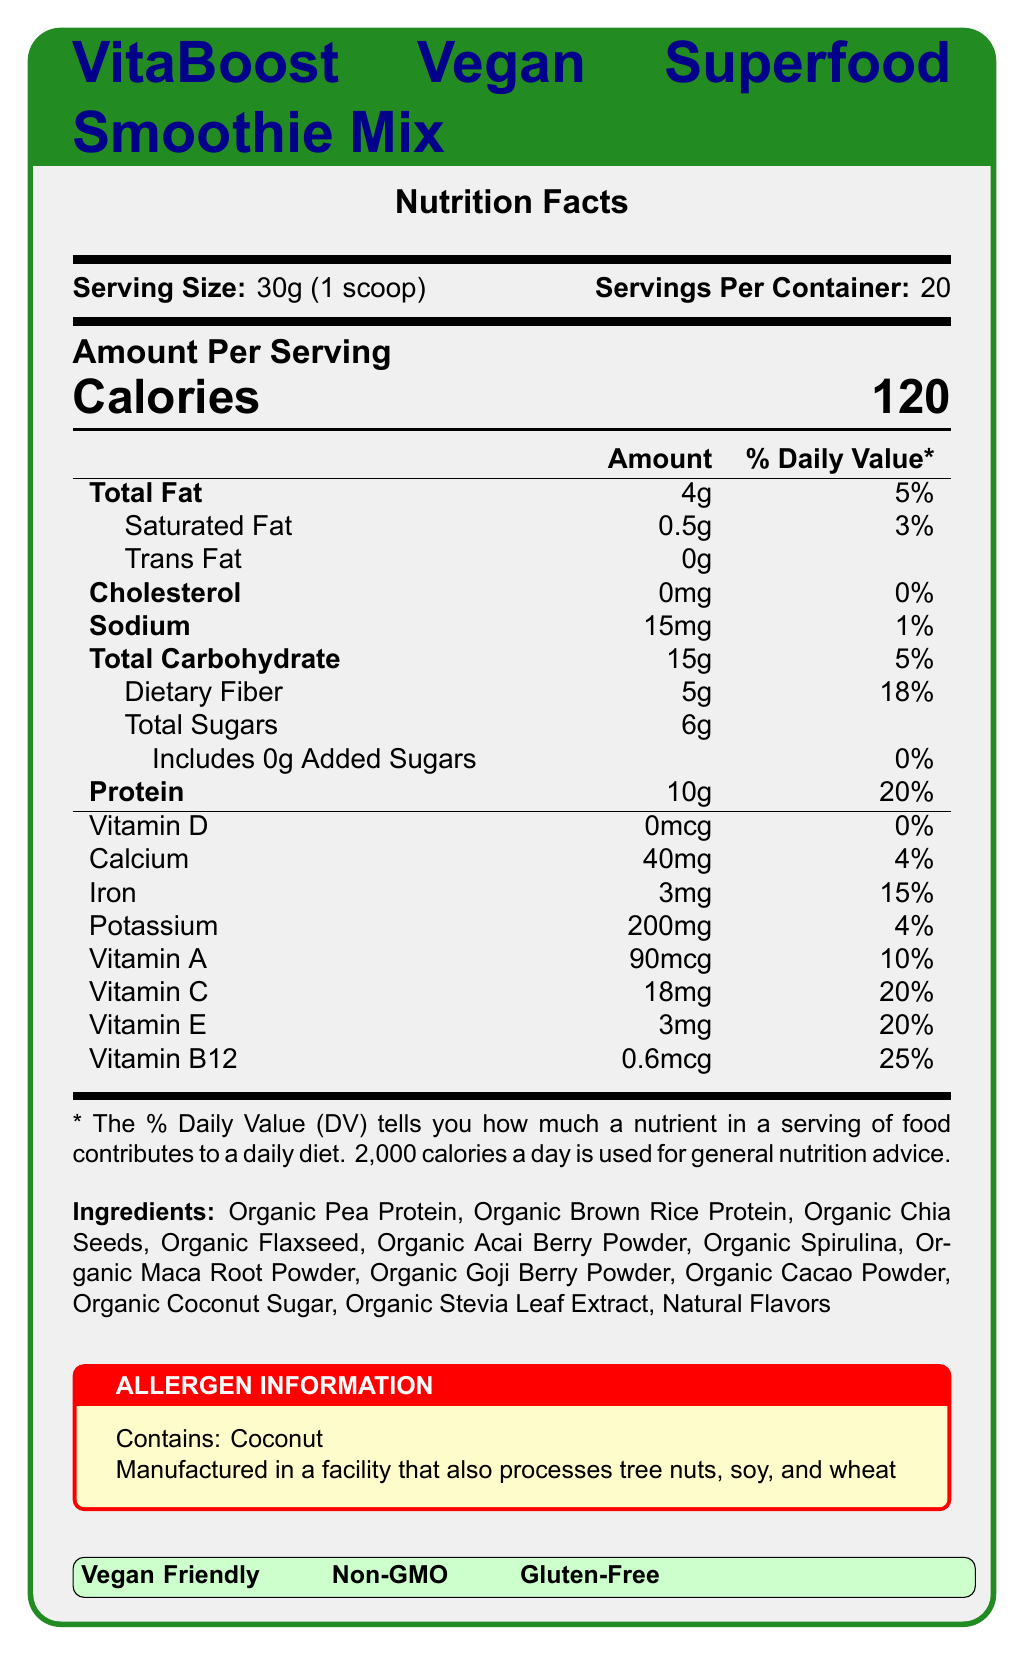what is the product name? The product name is clearly stated at the top of the document in the title section.
Answer: VitaBoost Vegan Superfood Smoothie Mix how many servings are in the container? The document states there are 20 servings per container.
Answer: 20 how many calories are in one serving? The document lists the calories per serving as 120.
Answer: 120 how much protein is in one serving? The nutrient information section specifies that there are 10 grams of protein per serving.
Answer: 10g what is the daily value percentage for dietary fiber? The daily value percentage for dietary fiber is noted as 18%.
Answer: 18% which vitamins are included in the nutrient information? A. Vitamin D, Vitamin C B. Vitamin E, Vitamin A C. Vitamin B12, Vitamin C D. All of the above All of the mentioned vitamins (Vitamin D, Vitamin C, Vitamin E, Vitamin A, and Vitamin B12) are included in the nutrient information.
Answer: D what is the serving size? A. 50g (1 scoop) B. 30g (1 scoop) C. 15g (2 scoops) D. 25g (1 scoop) The document mentions that the serving size is 30g (1 scoop).
Answer: B does the product contain any cholesterol? The document lists the amount of cholesterol as 0mg.
Answer: No is this product vegan-friendly? The document specifies vegan-friendly in the highlighted section near the bottom.
Answer: Yes what allergen warnings are provided? The allergen information section includes these specific warnings.
Answer: Contains: Coconut; Manufactured in a facility that also processes tree nuts, soy, and wheat what is the main idea of the document? The document is designed to inform about the nutritional content, ingredients, allergens, and specific health features of the product.
Answer: The document provides detailed nutrition facts, ingredient list, and allergen information for the VitaBoost Vegan Superfood Smoothie Mix, highlighting key nutrient values and labeling considerations. what is the total amount of sugars per serving? The document states that the total sugars amount per serving is 6g.
Answer: 6g what are the daily value percentages for iron and potassium? The nutrient information shows that iron has a daily value of 15% and potassium has a daily value of 4%.
Answer: 15% for iron and 4% for potassium which of the following ingredients is not listed? A. Organic Acai Berry Powder B. Organic Stevia Leaf Extract C. Organic Avocado Powder D. Organic Chia Seeds Organic Avocado Powder is not listed among the ingredients.
Answer: C is the product gluten-free? The gluten-free label is displayed in the highlighted section near the bottom.
Answer: Yes how much calcium is in one serving? The document specifies that there are 40mg of calcium per serving.
Answer: 40mg what is the font used in the document? The document does not provide any visual information about the font used for rendering; this information is part of the code and not visible in the document.
Answer: Not enough information 